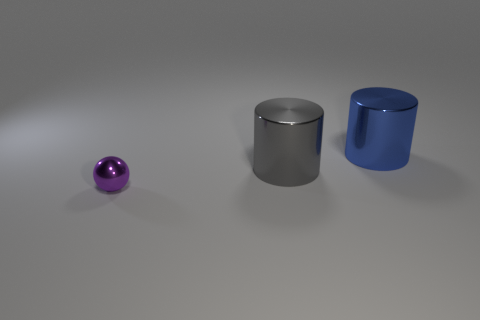Add 3 tiny things. How many objects exist? 6 Subtract all gray cylinders. How many cylinders are left? 1 Subtract 1 spheres. How many spheres are left? 0 Subtract all purple balls. How many gray cylinders are left? 1 Add 3 purple metal objects. How many purple metal objects exist? 4 Subtract 0 green cylinders. How many objects are left? 3 Subtract all balls. How many objects are left? 2 Subtract all green cylinders. Subtract all brown balls. How many cylinders are left? 2 Subtract all spheres. Subtract all blue metal cylinders. How many objects are left? 1 Add 3 gray objects. How many gray objects are left? 4 